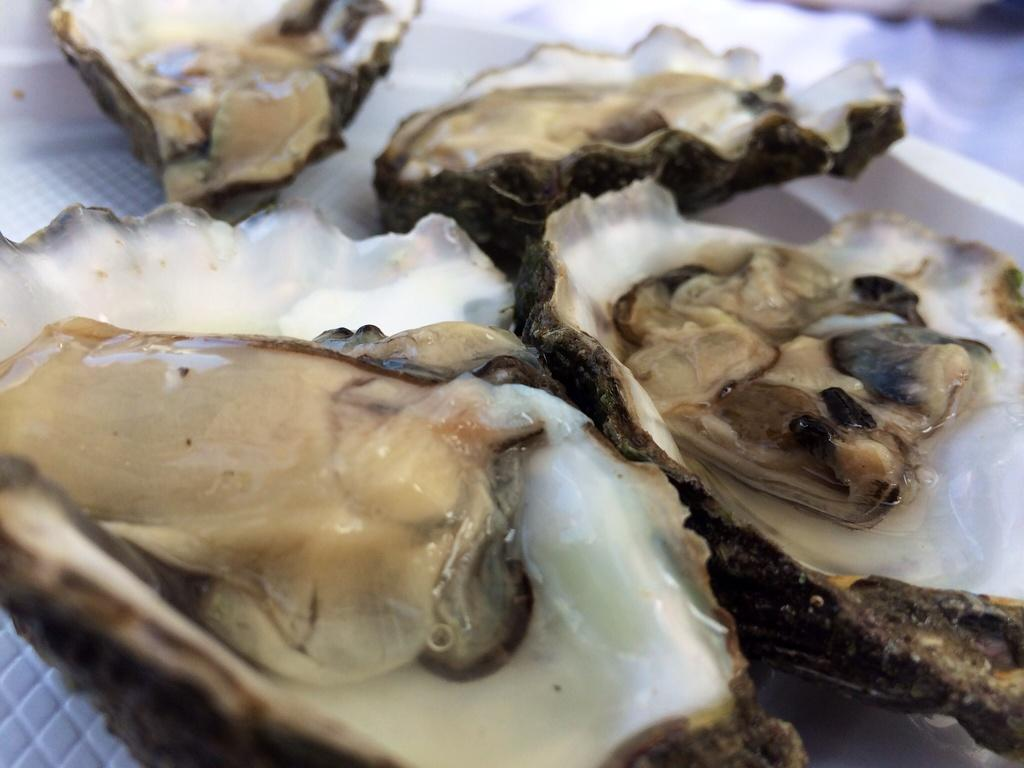What type of food is visible in the image? There are raw oysters in the image. Reasoning: Let's think step by identifying the main subject in the image, which is the raw oysters. We then formulate a question that focuses on the type of food present in the image, ensuring that the answer can be directly derived from the provided fact. Absurd Question/Answer: What type of camera is being used to take a bath in the image? There is no camera or bath present in the image; it only features raw oysters. Is there a fight happening between the oysters in the image? No, there is no fight depicted in the image; the oysters are simply raw and not engaged in any activity. 